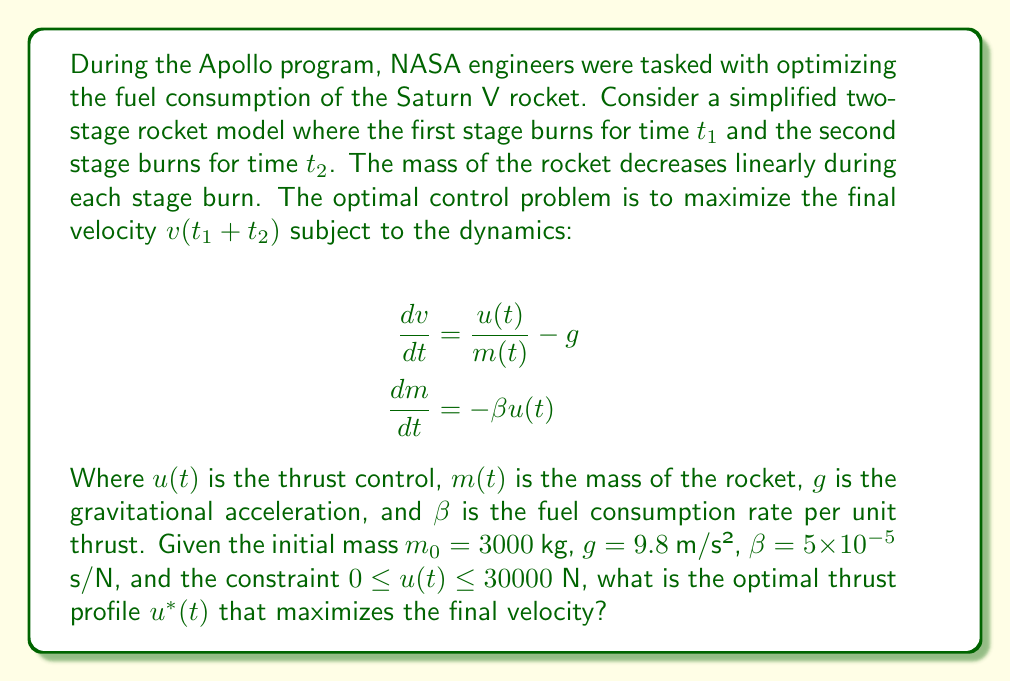Help me with this question. To solve this optimal control problem, we can use Pontryagin's Maximum Principle. Let's approach this step-by-step:

1) Define the Hamiltonian:
   $$H = \lambda_v \left(\frac{u}{m} - g\right) + \lambda_m (-\beta u)$$

2) The costate equations are:
   $$\frac{d\lambda_v}{dt} = -\frac{\partial H}{\partial v} = 0$$
   $$\frac{d\lambda_m}{dt} = -\frac{\partial H}{\partial m} = -\lambda_v \frac{u}{m^2}$$

3) The optimal control maximizes the Hamiltonian:
   $$u^* = \arg\max_{0 \leq u \leq 30000} H = \arg\max_{0 \leq u \leq 30000} \left(\frac{\lambda_v}{m} - \lambda_m \beta\right)u$$

4) This leads to a bang-bang control:
   $$u^*(t) = \begin{cases}
   30000 & \text{if } \frac{\lambda_v}{m} - \lambda_m \beta > 0 \\
   0 & \text{if } \frac{\lambda_v}{m} - \lambda_m \beta < 0
   \end{cases}$$

5) Since $\lambda_v$ is constant (from step 2), and $m$ is decreasing, the switching function $\frac{\lambda_v}{m} - \lambda_m \beta$ is monotonically increasing. This means there can be at most one switch from full thrust to zero thrust.

6) Given the objective to maximize final velocity, it's optimal to use full thrust until all fuel is consumed.

7) The burn time can be calculated from the mass equation:
   $$t_{burn} = \frac{m_0}{\beta u_{max}} = \frac{3000}{5 \times 10^{-5} \times 30000} = 2000 \text{ s}$$

Therefore, the optimal thrust profile is full thrust for 2000 seconds, followed by zero thrust.
Answer: The optimal thrust profile $u^*(t)$ is:

$$u^*(t) = \begin{cases}
30000 \text{ N} & \text{for } 0 \leq t \leq 2000 \text{ s} \\
0 \text{ N} & \text{for } t > 2000 \text{ s}
\end{cases}$$ 